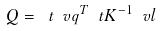Convert formula to latex. <formula><loc_0><loc_0><loc_500><loc_500>Q = \ t { \ v q } ^ { T } \ t K ^ { - 1 } \ v l</formula> 